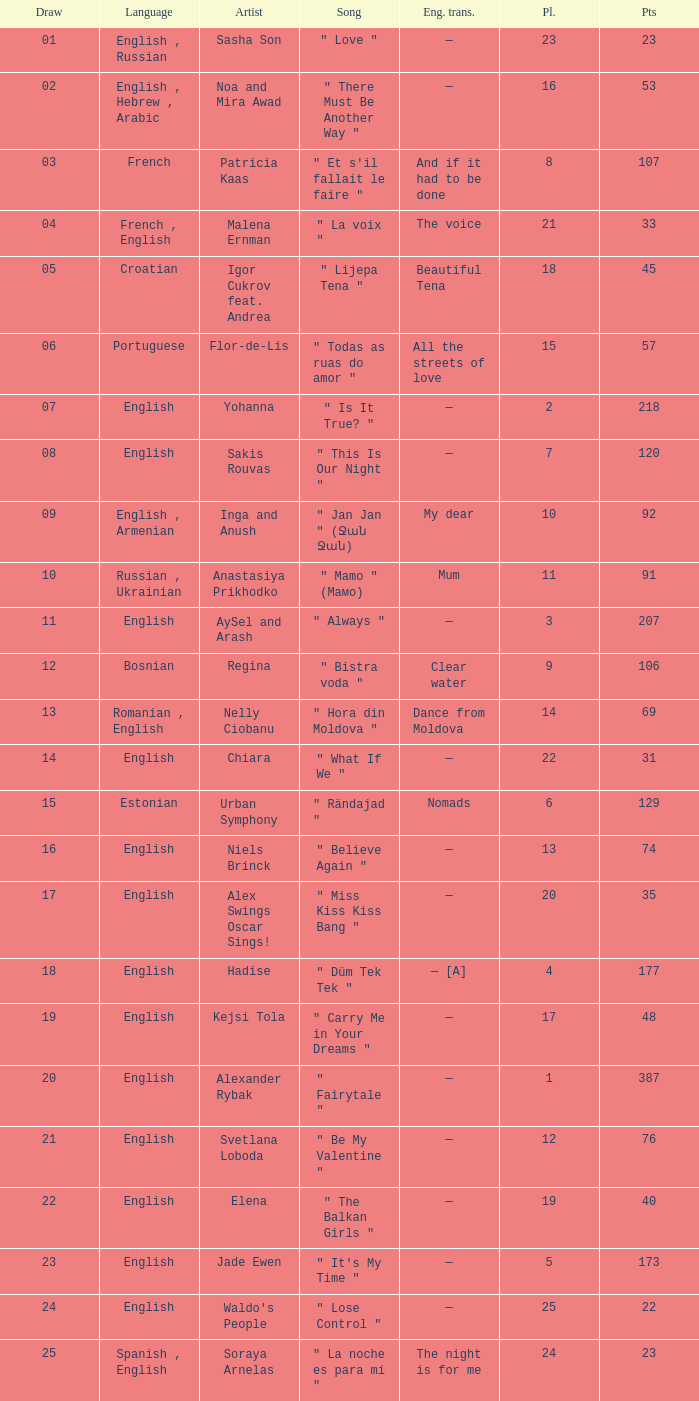What was the average place for the song that had 69 points and a draw smaller than 13? None. 